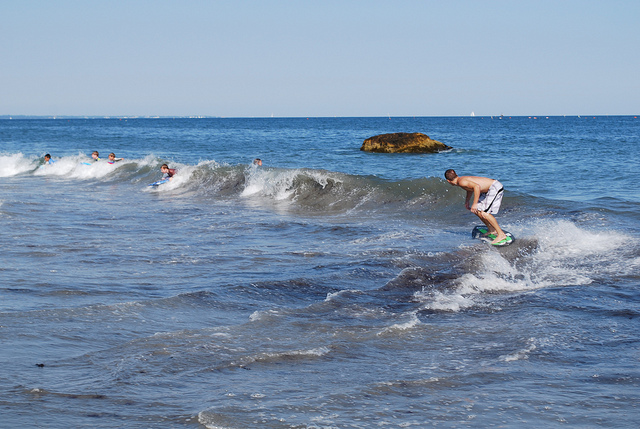<image>What animal is in the water? I am not sure. There might be a human or a whale in the water, or there might be no animal at all. What animal is in the water? I am not sure what animal is in the water. It can be a human or a whale. 